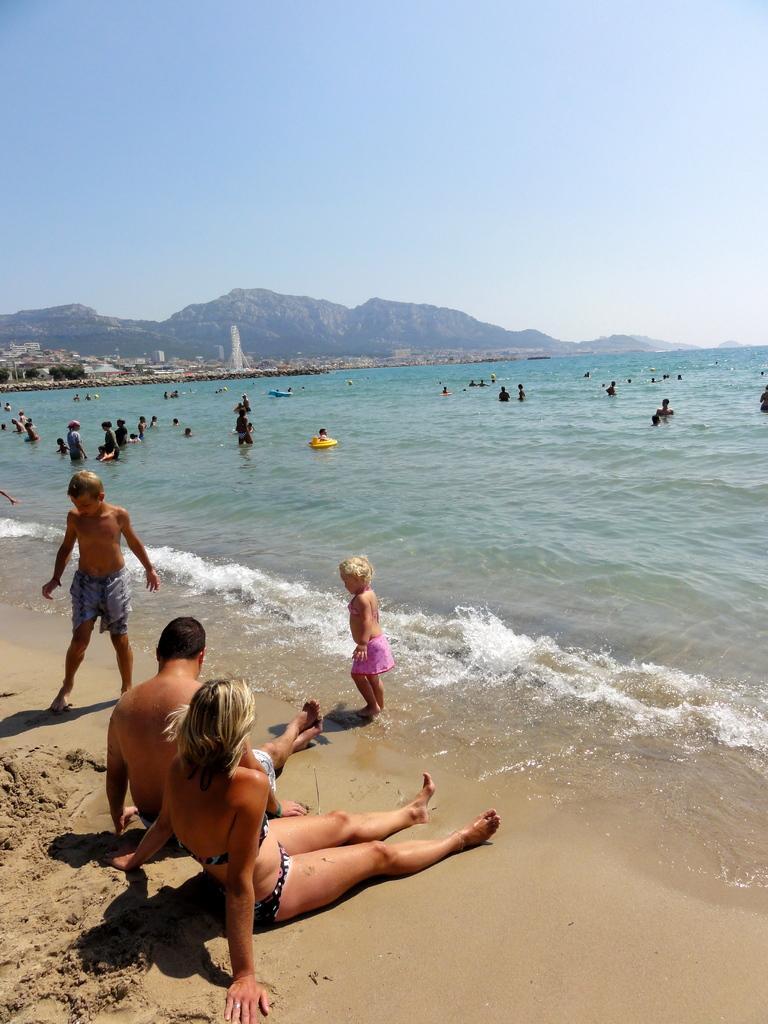How would you summarize this image in a sentence or two? In this image we can see many people. Also there is a sea shore. In the back there are hills and there is sky. 